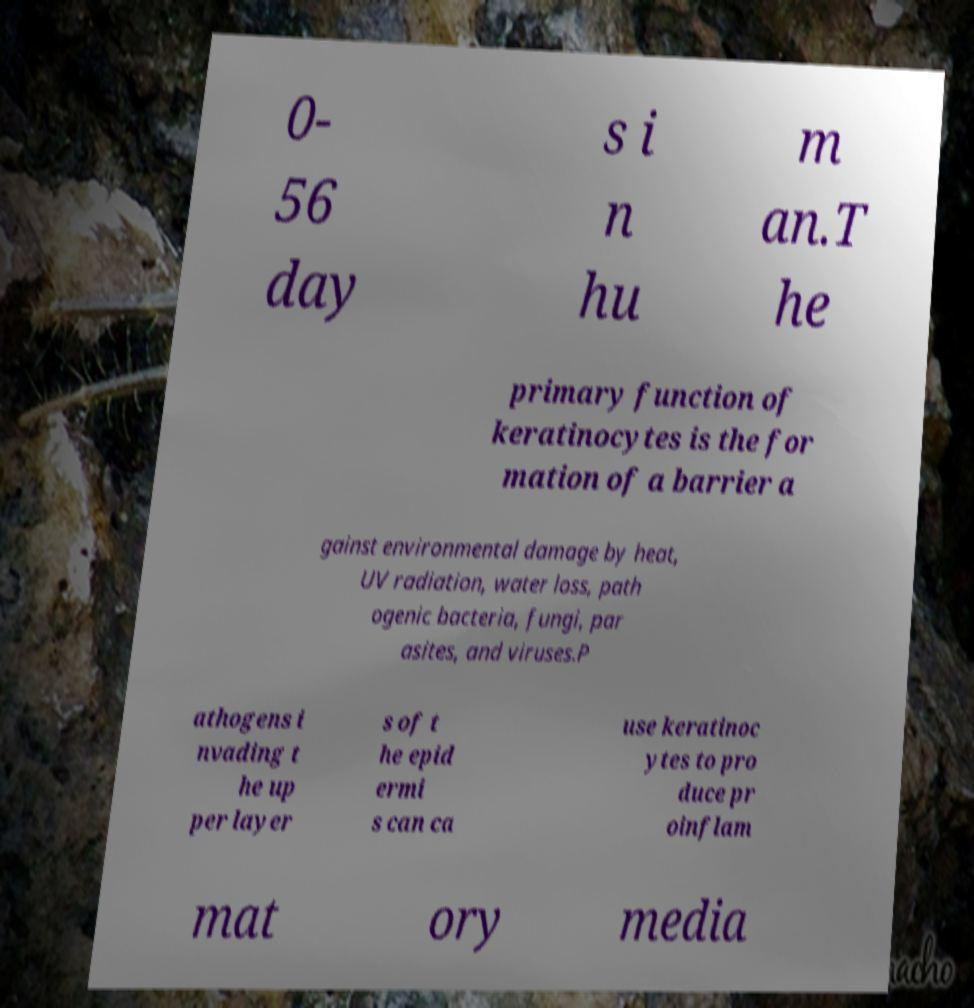Could you assist in decoding the text presented in this image and type it out clearly? 0- 56 day s i n hu m an.T he primary function of keratinocytes is the for mation of a barrier a gainst environmental damage by heat, UV radiation, water loss, path ogenic bacteria, fungi, par asites, and viruses.P athogens i nvading t he up per layer s of t he epid ermi s can ca use keratinoc ytes to pro duce pr oinflam mat ory media 